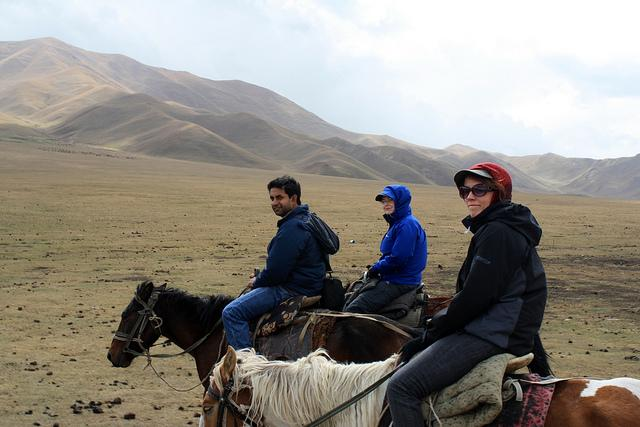What are the people turning to look at? camera 